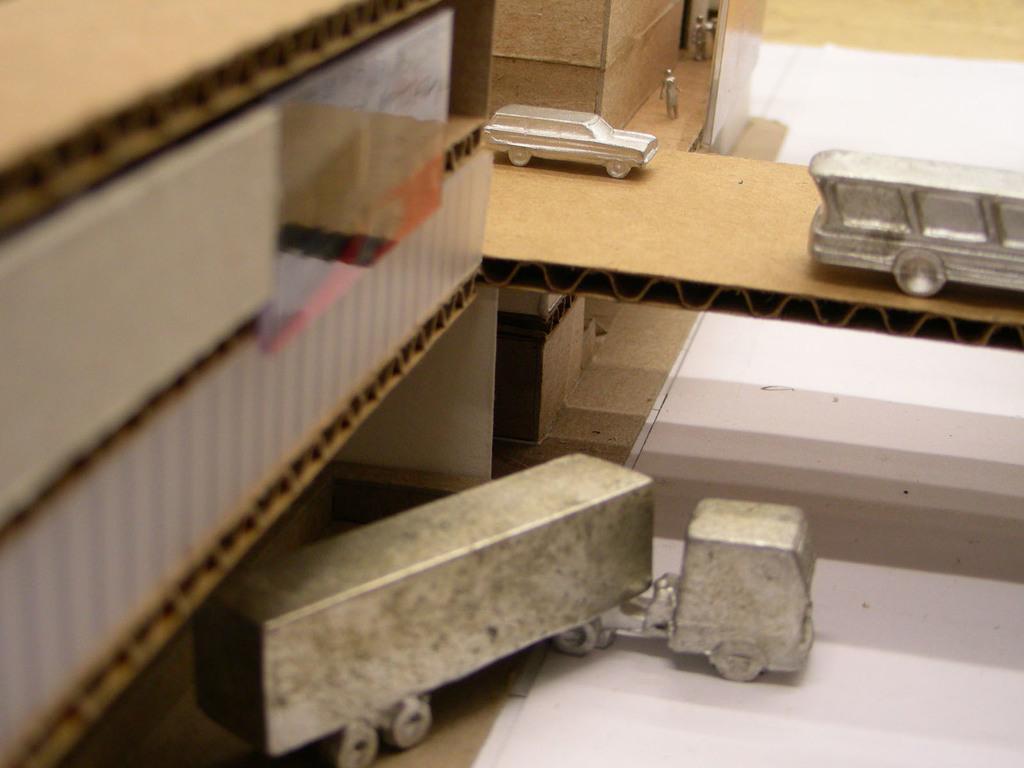In one or two sentences, can you explain what this image depicts? In this image we can see some cardboard box. We can also see the depiction of persons and also vehicles on the path and also on the surface. 